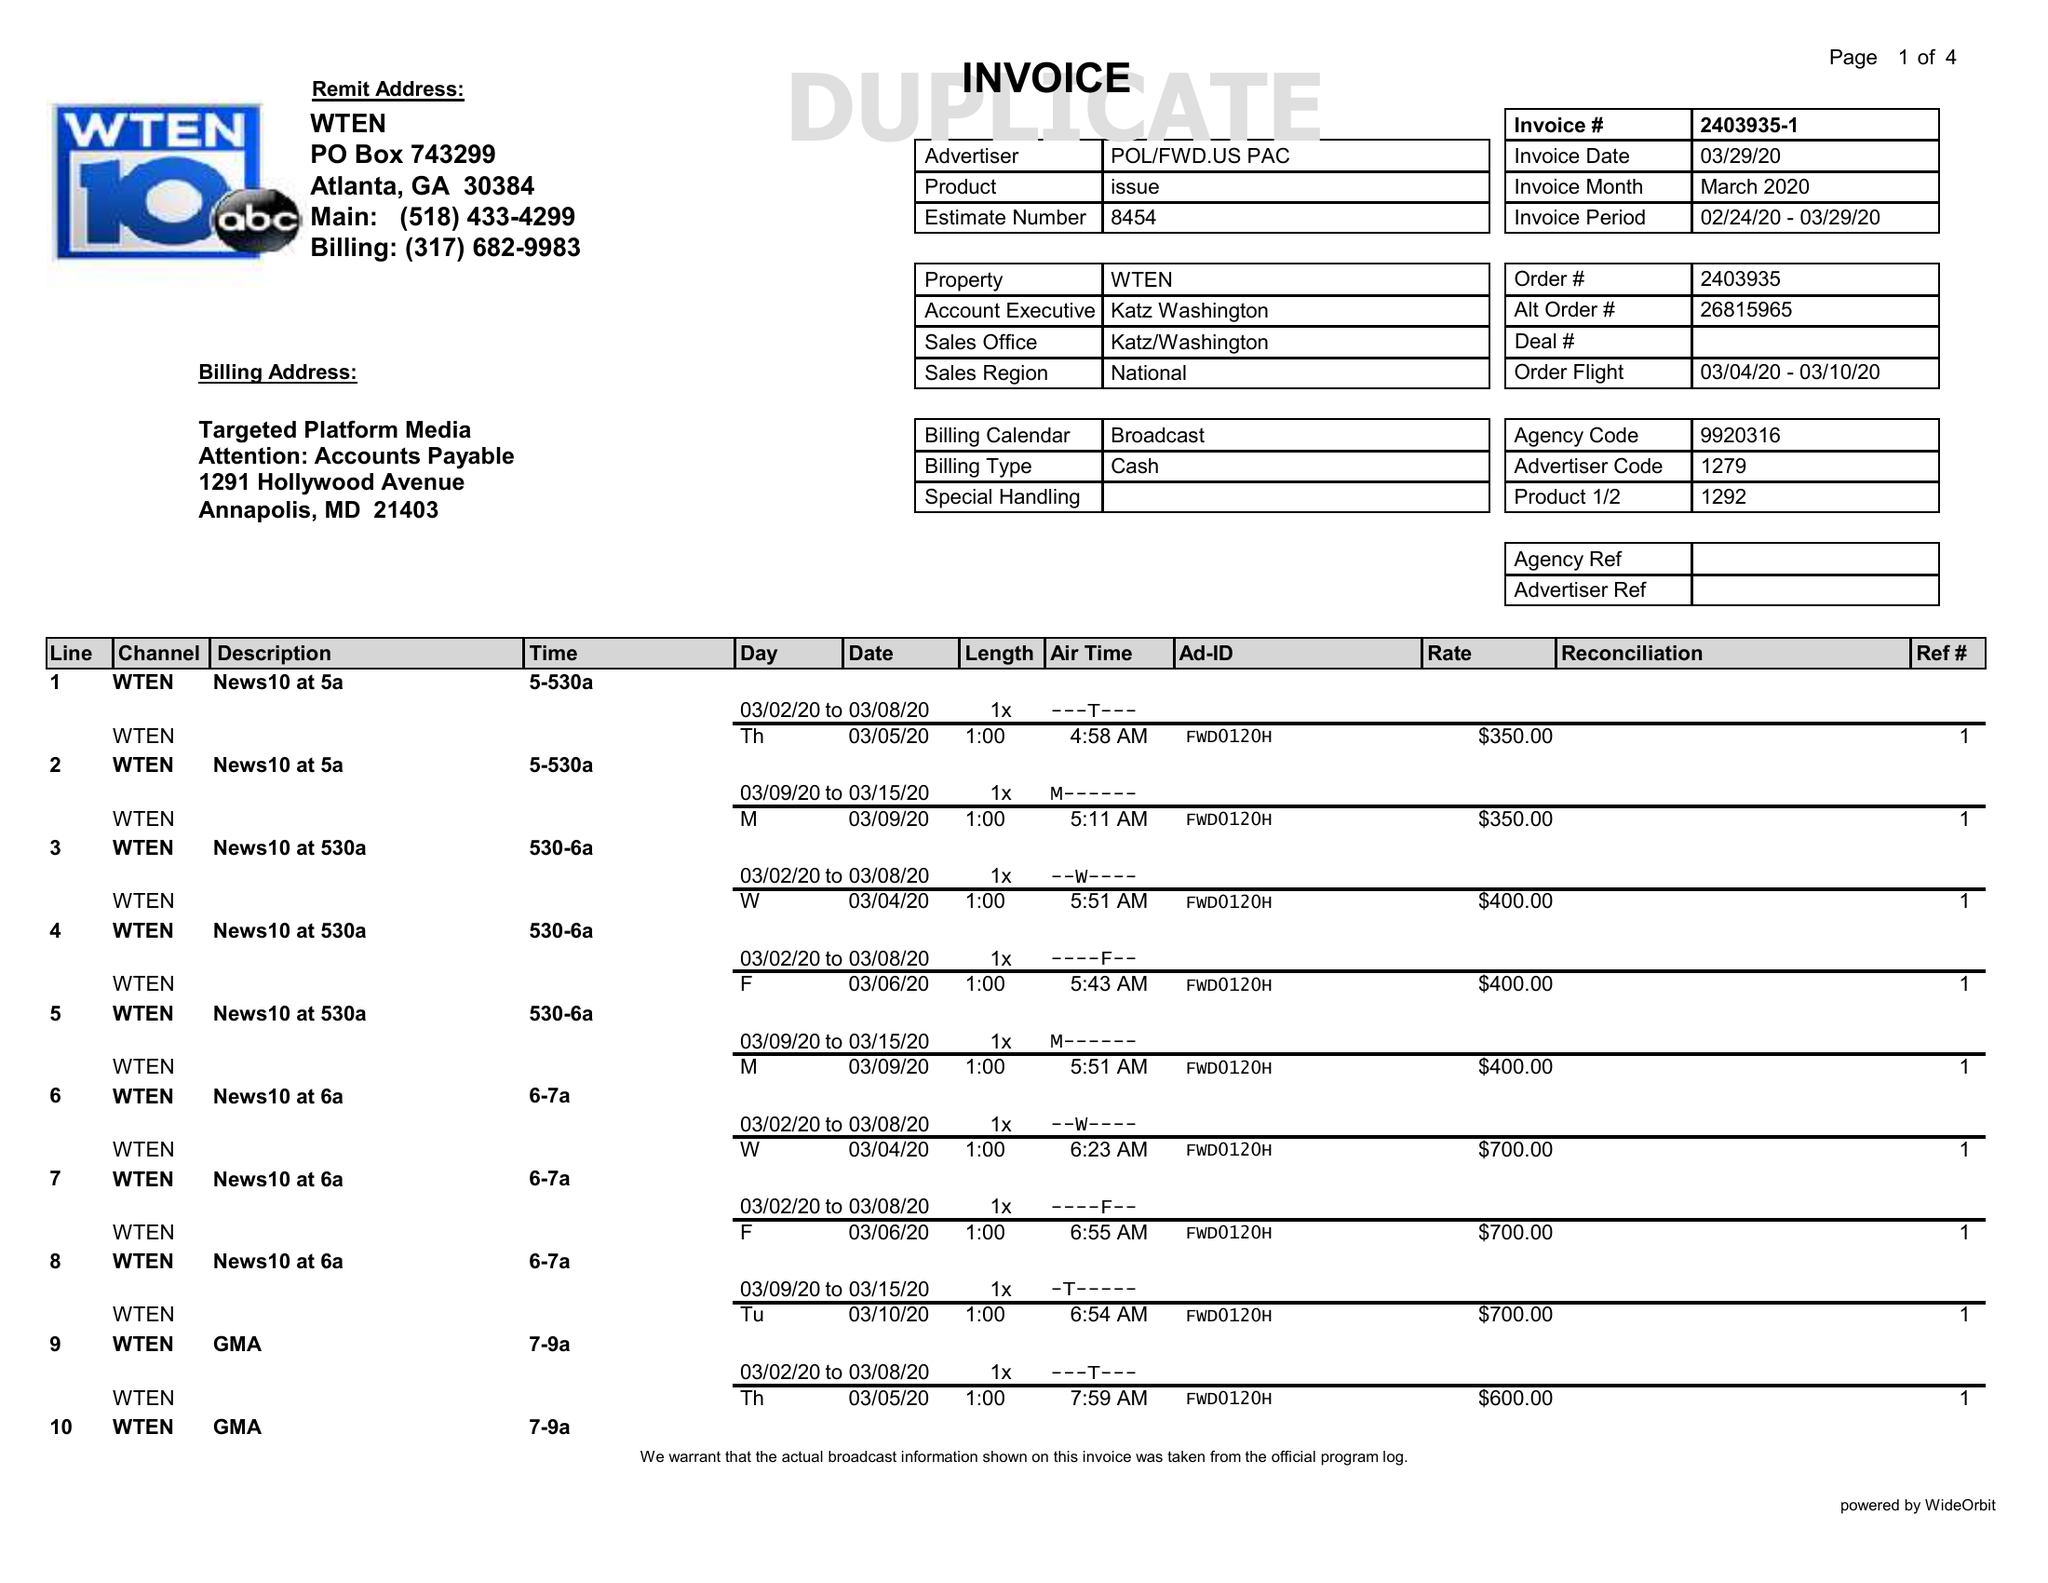What is the value for the flight_to?
Answer the question using a single word or phrase. 03/10/20 